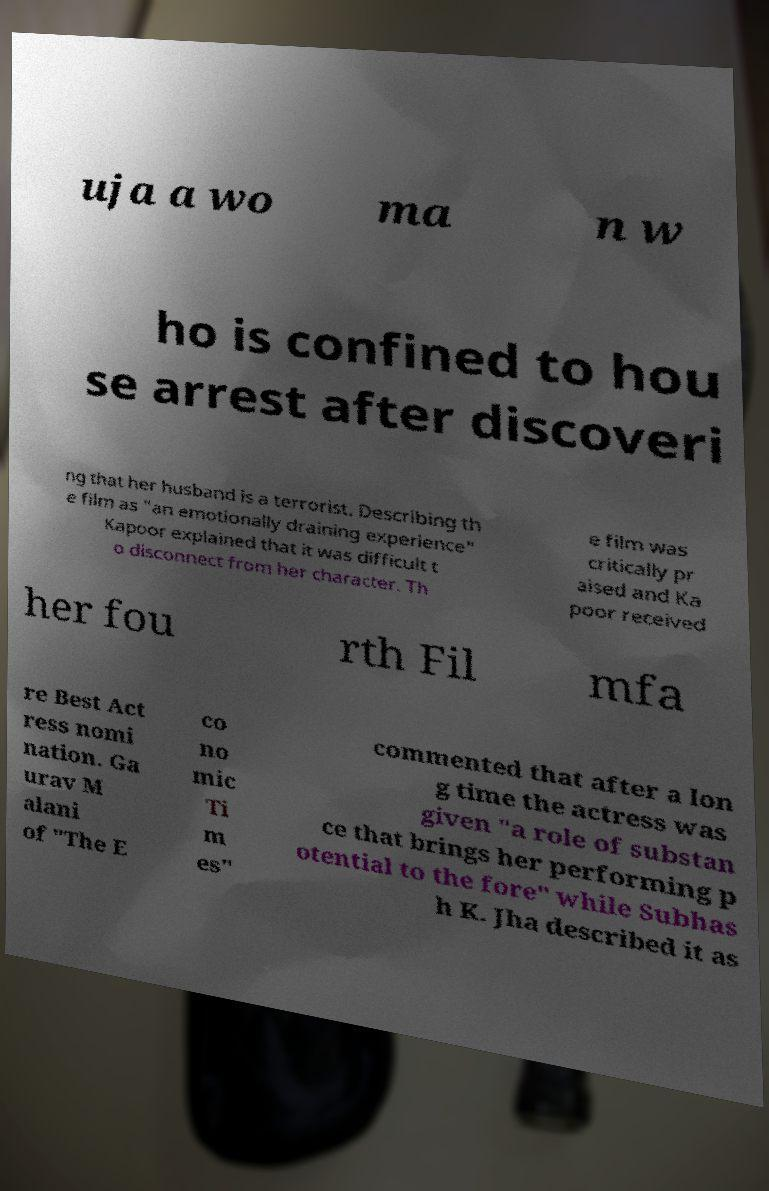I need the written content from this picture converted into text. Can you do that? uja a wo ma n w ho is confined to hou se arrest after discoveri ng that her husband is a terrorist. Describing th e film as "an emotionally draining experience" Kapoor explained that it was difficult t o disconnect from her character. Th e film was critically pr aised and Ka poor received her fou rth Fil mfa re Best Act ress nomi nation. Ga urav M alani of "The E co no mic Ti m es" commented that after a lon g time the actress was given "a role of substan ce that brings her performing p otential to the fore" while Subhas h K. Jha described it as 